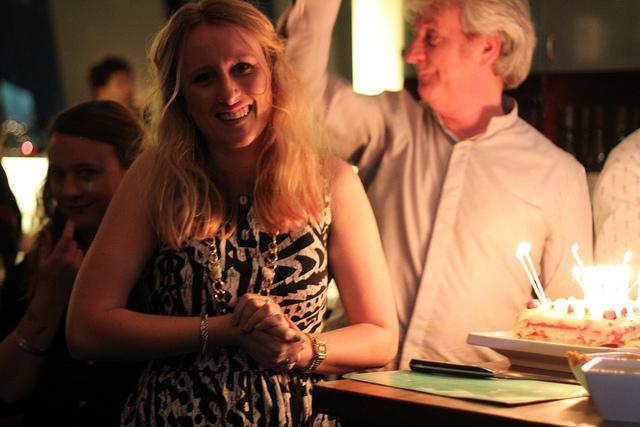How is the man's hair styled?
Concise answer only. Straight. Is the man looking at the camera?
Answer briefly. No. What is on fire?
Be succinct. Candles. Do they look like they're having fun?
Keep it brief. Yes. 